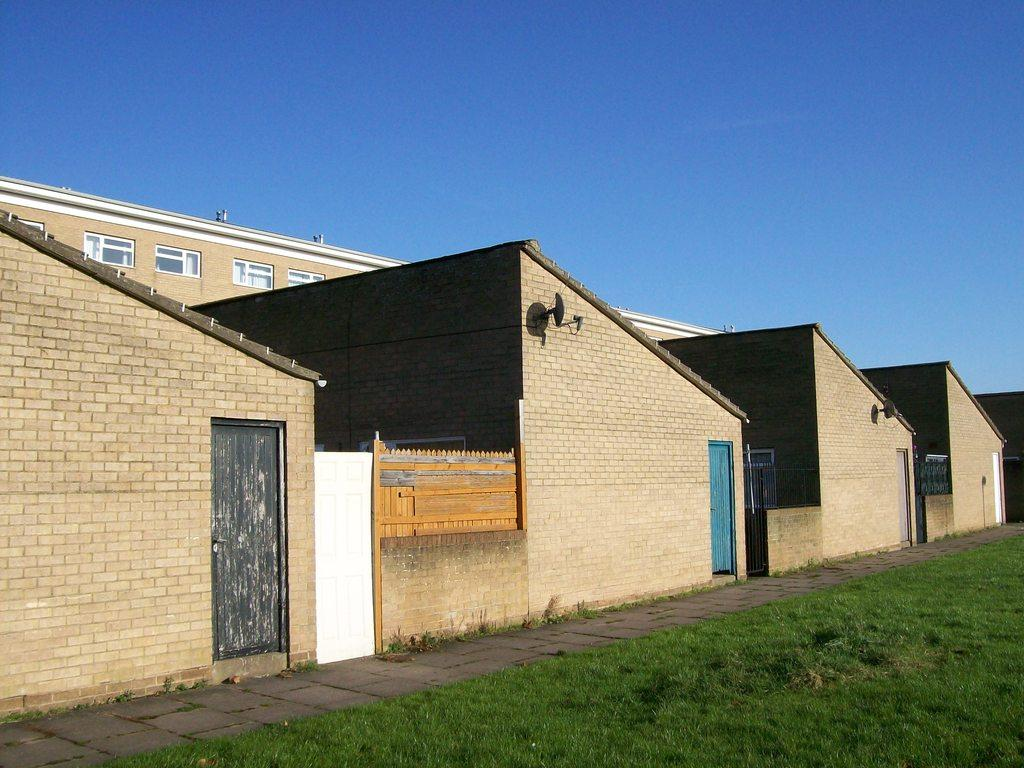What type of vegetation is present in the image? There is grass in the image. What type of structures can be seen in the image? There are roof houses and a building in the image. Where is the building located in the image? The building is in the middle of the image. What is visible at the top of the image? The sky is visible at the top of the image. What type of silk is draped over the pot in the room in the image? There is no silk, pot, or room present in the image. 